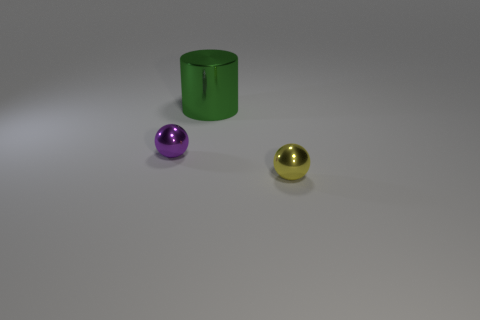Is there anything else that has the same size as the metal cylinder?
Your answer should be compact. No. Is there any other thing that has the same shape as the tiny purple thing?
Give a very brief answer. Yes. What number of things are shiny objects that are in front of the green cylinder or green cylinders?
Ensure brevity in your answer.  3. Do the yellow thing and the tiny purple metal object have the same shape?
Your answer should be compact. Yes. How many other things are there of the same size as the green shiny thing?
Give a very brief answer. 0. The cylinder has what color?
Provide a succinct answer. Green. What number of tiny objects are either brown cylinders or metal cylinders?
Your answer should be compact. 0. Is the size of the metallic sphere right of the purple metallic thing the same as the sphere on the left side of the large metal object?
Keep it short and to the point. Yes. There is a purple metal thing that is the same shape as the tiny yellow object; what is its size?
Offer a terse response. Small. Are there more small purple spheres right of the tiny yellow sphere than yellow spheres to the right of the big metal cylinder?
Provide a short and direct response. No. 